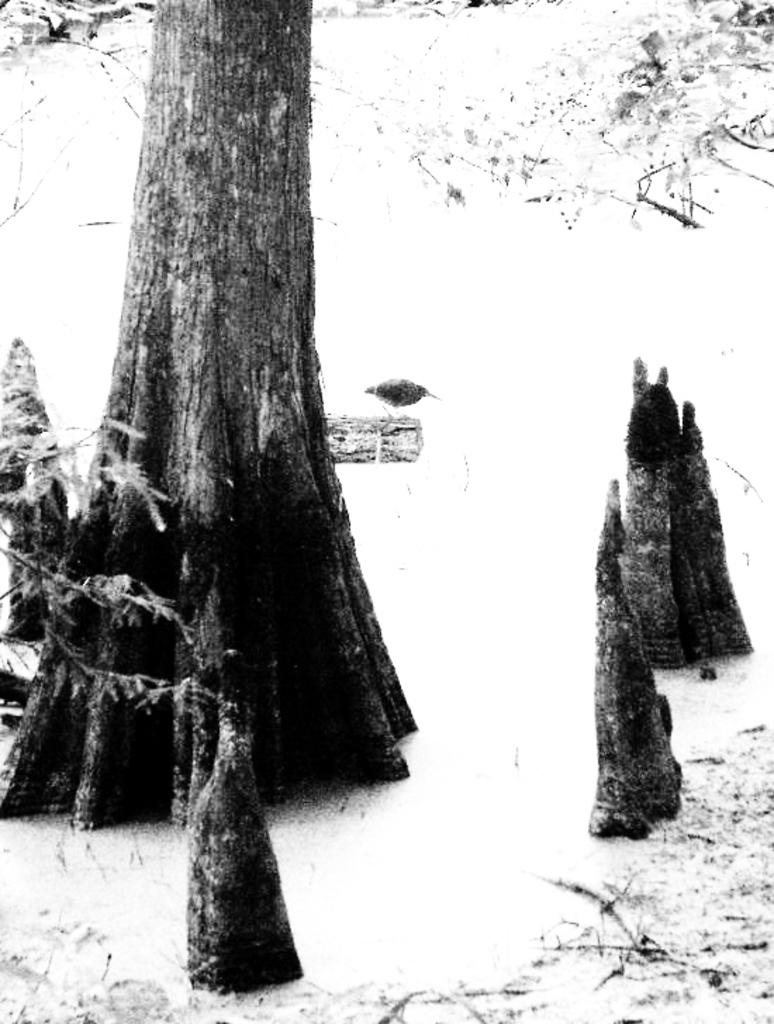What type of plant can be seen in the image? There is a tree in the image. What color is the background of the image? The background of the image is white. Can you tell me how many people are swimming in the image? There is no swimming or people present in the image; it features a tree with a white background. 